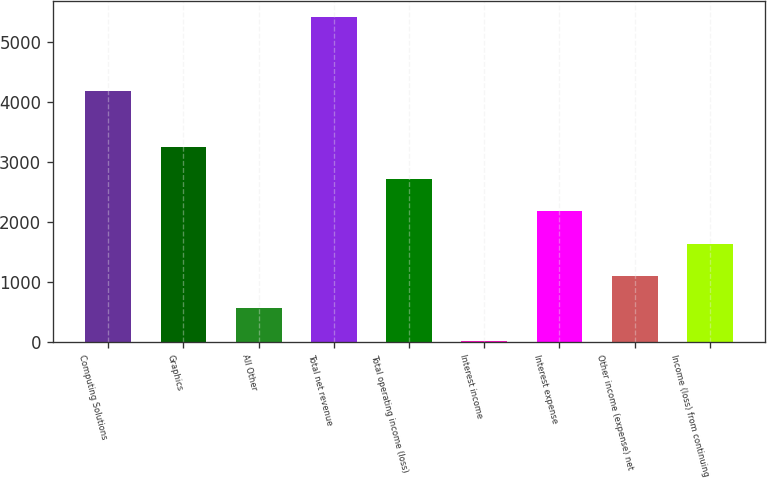Convert chart to OTSL. <chart><loc_0><loc_0><loc_500><loc_500><bar_chart><fcel>Computing Solutions<fcel>Graphics<fcel>All Other<fcel>Total net revenue<fcel>Total operating income (loss)<fcel>Interest income<fcel>Interest expense<fcel>Other income (expense) net<fcel>Income (loss) from continuing<nl><fcel>4170<fcel>3248.2<fcel>554.7<fcel>5403<fcel>2709.5<fcel>16<fcel>2170.8<fcel>1093.4<fcel>1632.1<nl></chart> 